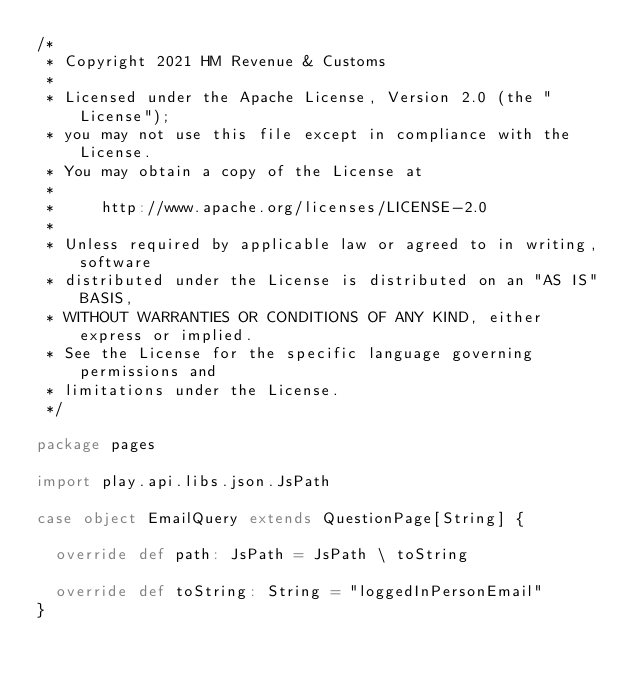Convert code to text. <code><loc_0><loc_0><loc_500><loc_500><_Scala_>/*
 * Copyright 2021 HM Revenue & Customs
 *
 * Licensed under the Apache License, Version 2.0 (the "License");
 * you may not use this file except in compliance with the License.
 * You may obtain a copy of the License at
 *
 *     http://www.apache.org/licenses/LICENSE-2.0
 *
 * Unless required by applicable law or agreed to in writing, software
 * distributed under the License is distributed on an "AS IS" BASIS,
 * WITHOUT WARRANTIES OR CONDITIONS OF ANY KIND, either express or implied.
 * See the License for the specific language governing permissions and
 * limitations under the License.
 */

package pages

import play.api.libs.json.JsPath

case object EmailQuery extends QuestionPage[String] {

  override def path: JsPath = JsPath \ toString

  override def toString: String = "loggedInPersonEmail"
}
</code> 